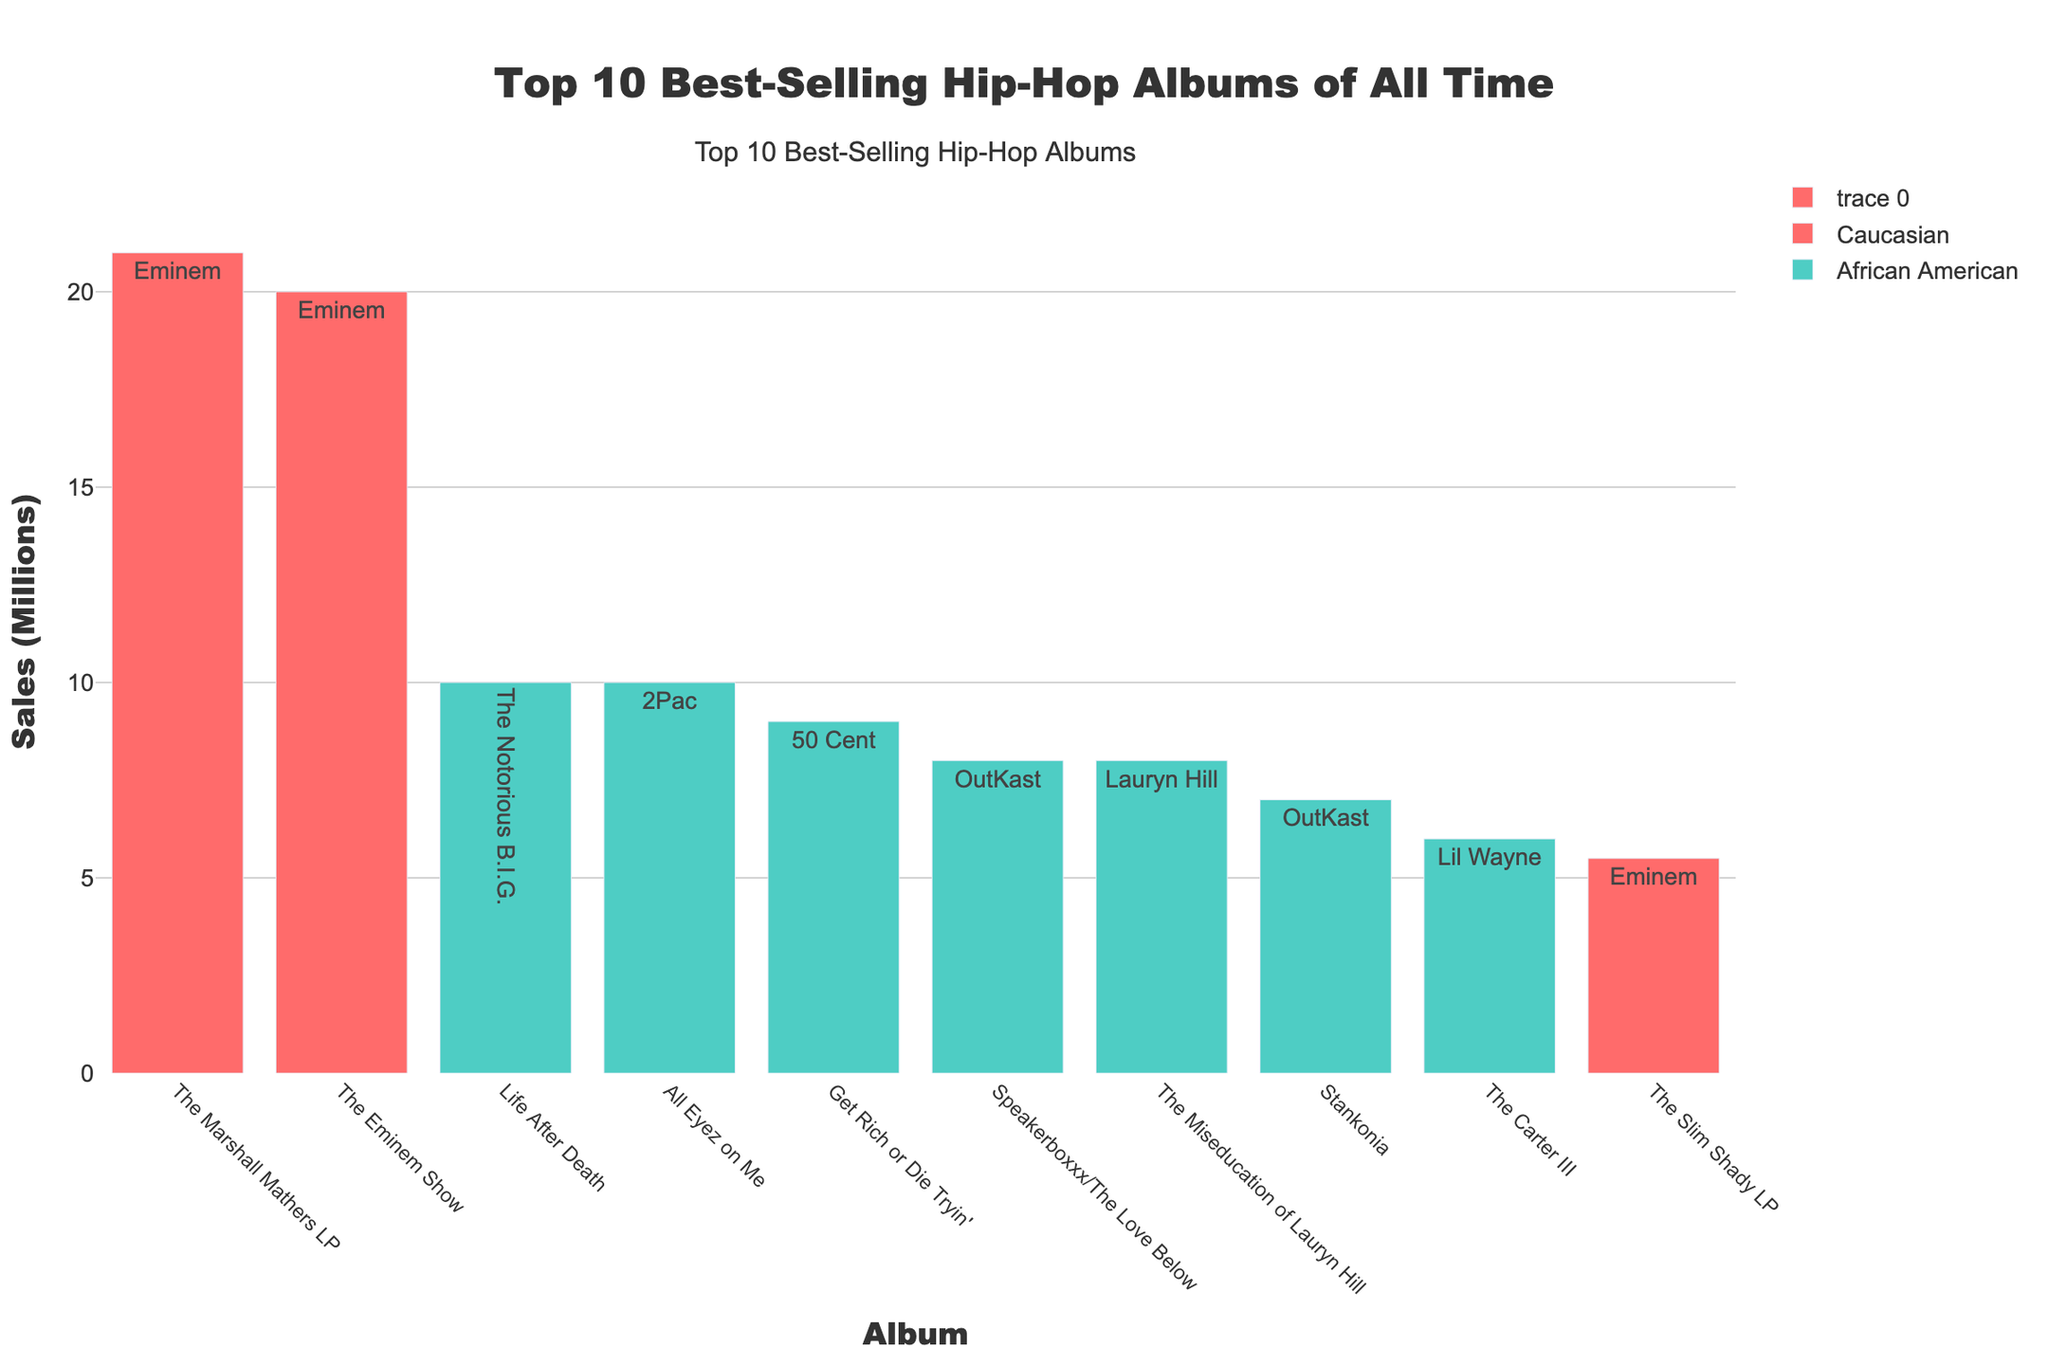Which album sold the highest number of copies? The Marshall Mathers LP by Eminem shows the tallest bar, indicating the highest sales at 21 million copies.
Answer: The Marshall Mathers LP Which artist has the most albums in the top 10 list? Eminem and OutKast each appear three times. Eminem's albums are The Marshall Mathers LP, The Eminem Show, and The Slim Shady LP, while OutKast’s albums are Speakerboxxx/The Love Below, Stankonia, and one more.
Answer: Eminem and OutKast What is the total sales figure for all albums by African American artists? Add up the sales figures for Life After Death (10M), All Eyez on Me (10M), Get Rich or Die Tryin' (9M), Speakerboxxx/The Love Below (8M), The Miseducation of Lauryn Hill (8M), Stankonia (7M), and The Carter III (6M): 10 + 10 + 9 + 8 + 8 + 7 + 6 = 58M.
Answer: 58 million Which album by Eminem has the least sales? Comparing Eminem’s albums, The Slim Shady LP sold 5.5 million copies, which is less than The Marshall Mathers LP (21M) and The Eminem Show (20M).
Answer: The Slim Shady LP How much more did The Marshall Mathers LP sell than The Carter III? The Marshall Mathers LP sold 21M copies, and The Carter III sold 6M, so the difference is 21 - 6 = 15M.
Answer: 15 million Which albums have sales between 7 and 10 million copies? The albums in this range are Get Rich or Die Tryin' (9M), Speakerboxxx/The Love Below (8M), The Miseducation of Lauryn Hill (8M), and Stankonia (7M).
Answer: Get Rich or Die Tryin', Speakerboxxx/The Love Below, The Miseducation of Lauryn Hill, Stankonia What's the average sales figure of albums by Caucasian artists? Eminem's albums are The Marshall Mathers LP (21M), The Eminem Show (20M), and The Slim Shady LP (5.5M). The average is (21 + 20 + 5.5) / 3 = 46.5 / 3 ≈ 15.5M.
Answer: 15.5 million How many albums in the top 10 list have sold exactly 10 million copies? The albums in this category are Life After Death (10M) and All Eyez on Me (10M).
Answer: 2 Which ethnicity has a higher total number of top 10 albums, and by how much? Caucasian artists have 3 albums (all by Eminem), and African American artists have 7 albums. The difference is 7 - 3 = 4.
Answer: African American, 4 What is the total sales difference between the top-selling and the least-selling albums in the top 10 list? The top-selling album is The Marshall Mathers LP (21M), and the least-selling album is The Slim Shady LP (5.5M). The difference is 21 - 5.5 = 15.5M.
Answer: 15.5 million 